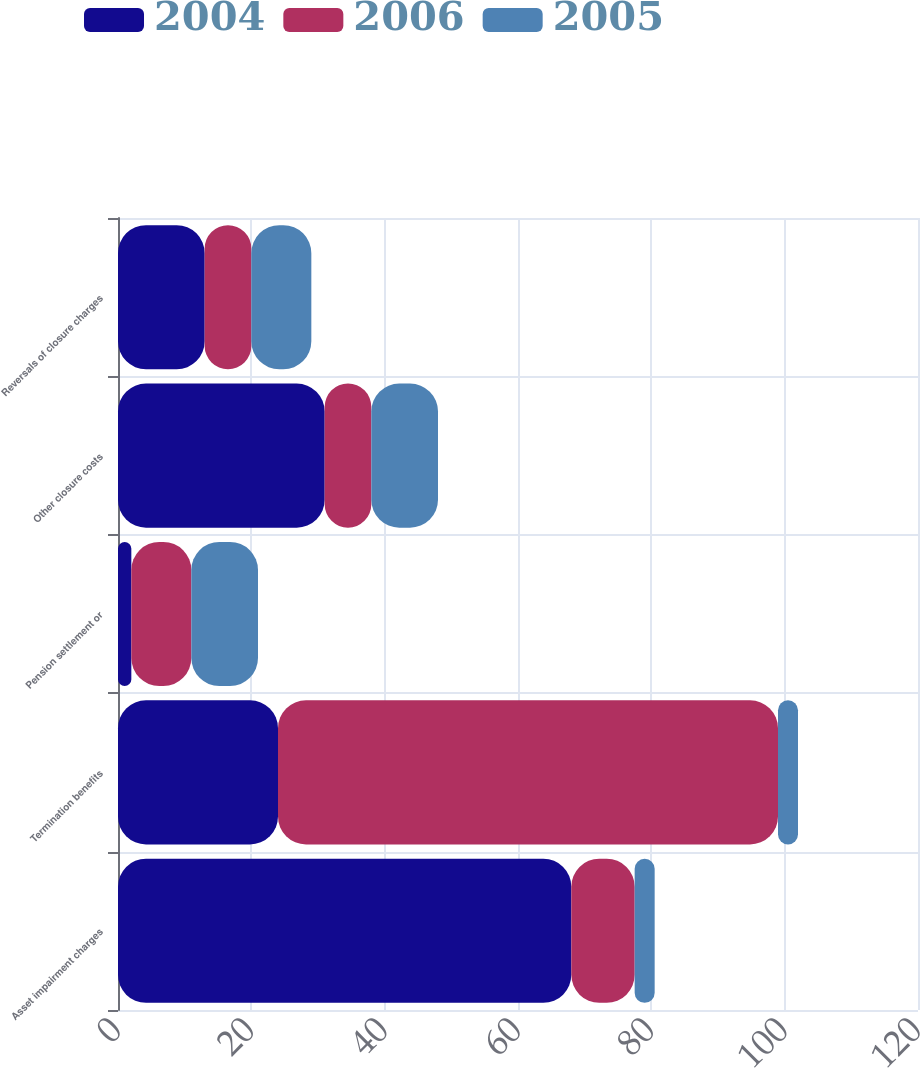Convert chart. <chart><loc_0><loc_0><loc_500><loc_500><stacked_bar_chart><ecel><fcel>Asset impairment charges<fcel>Termination benefits<fcel>Pension settlement or<fcel>Other closure costs<fcel>Reversals of closure charges<nl><fcel>2004<fcel>68<fcel>24<fcel>2<fcel>31<fcel>13<nl><fcel>2006<fcel>9.5<fcel>75<fcel>9<fcel>7<fcel>7<nl><fcel>2005<fcel>3<fcel>3<fcel>10<fcel>10<fcel>9<nl></chart> 